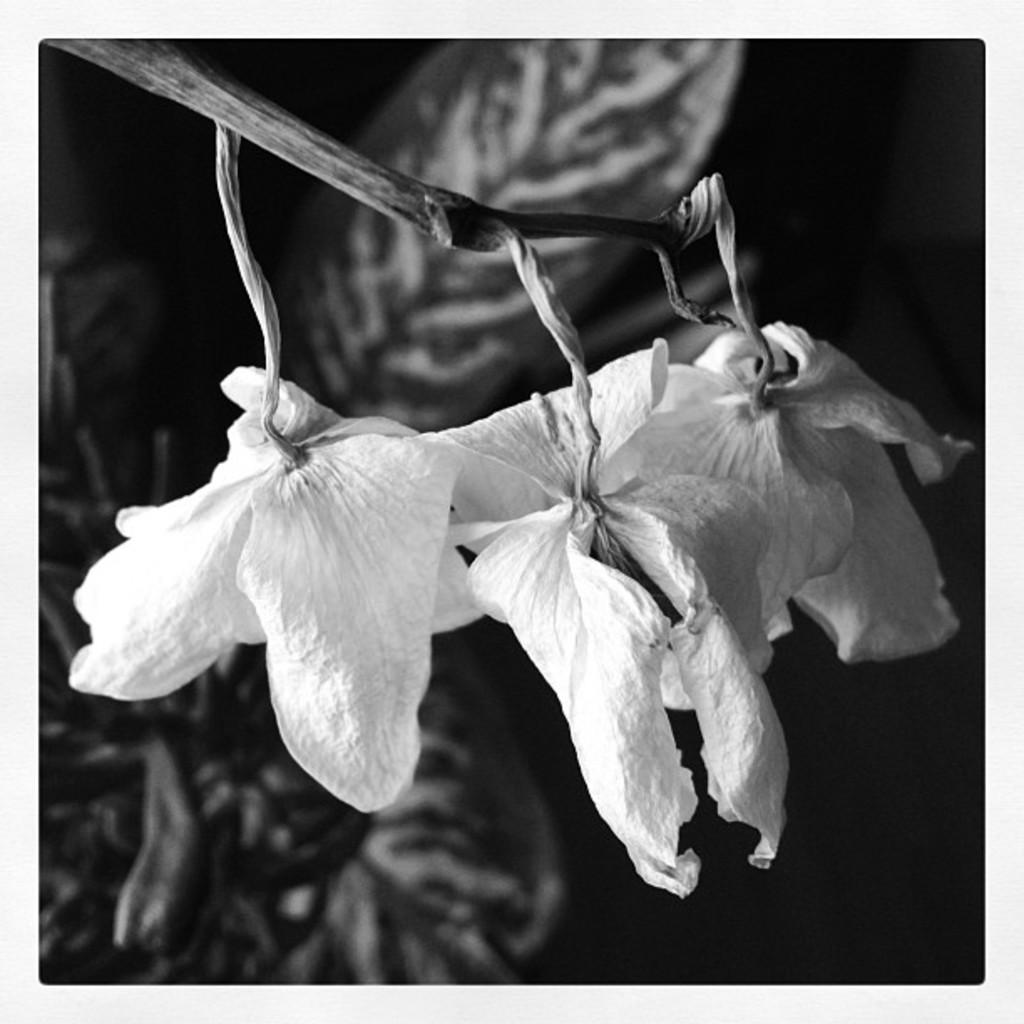What is the color scheme of the image? The image is black and white. What can be seen in the image? There are flowers of a plant in the image. What else is visible in the background of the image? There are leaves visible in the background of the image. What type of ornament is hanging from the cow in the image? There is no cow or ornament present in the image. What property does the plant belong to in the image? The image does not provide information about the ownership or location of the plant. 